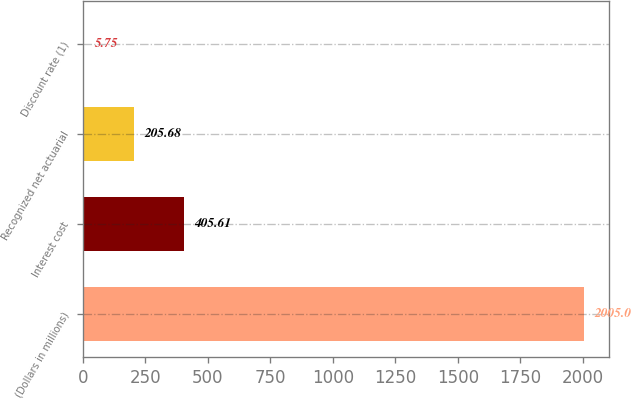Convert chart to OTSL. <chart><loc_0><loc_0><loc_500><loc_500><bar_chart><fcel>(Dollars in millions)<fcel>Interest cost<fcel>Recognized net actuarial<fcel>Discount rate (1)<nl><fcel>2005<fcel>405.61<fcel>205.68<fcel>5.75<nl></chart> 